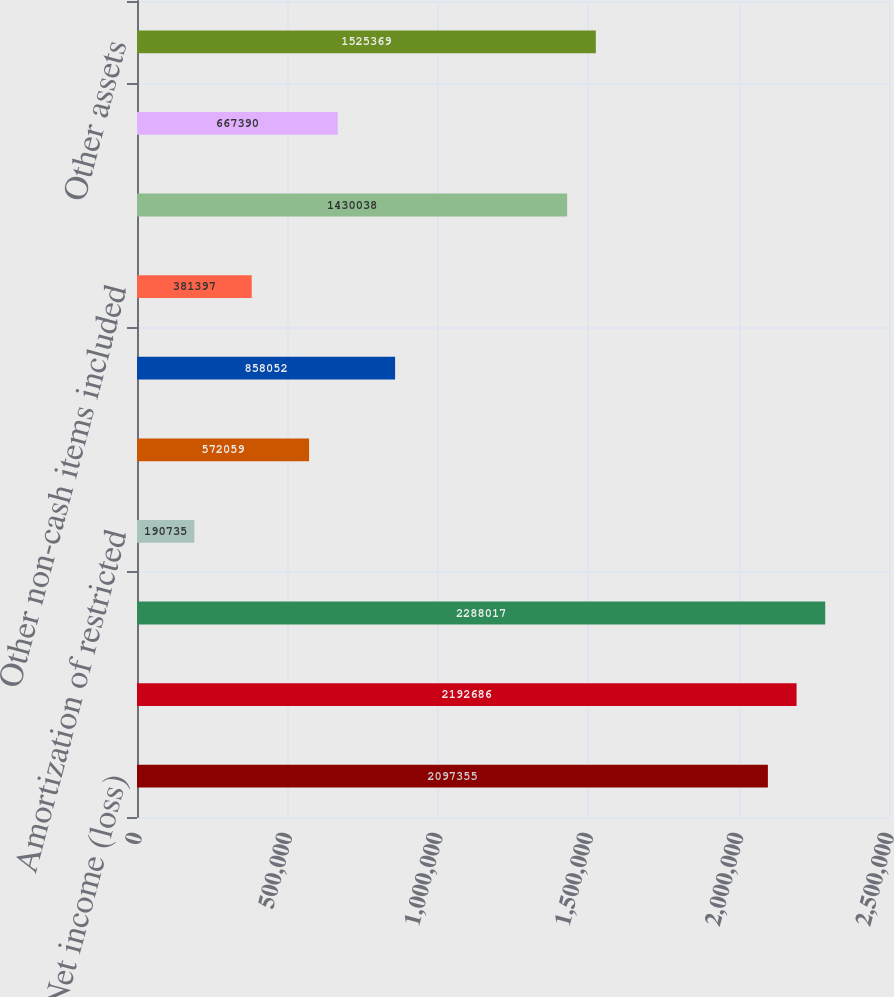Convert chart. <chart><loc_0><loc_0><loc_500><loc_500><bar_chart><fcel>Net income (loss)<fcel>Net income (loss) from<fcel>Depreciation and amortization<fcel>Amortization of restricted<fcel>Provision for bad debts<fcel>Deferred taxes net<fcel>Other non-cash items included<fcel>Receivables net<fcel>Receivables from related<fcel>Other assets<nl><fcel>2.09736e+06<fcel>2.19269e+06<fcel>2.28802e+06<fcel>190735<fcel>572059<fcel>858052<fcel>381397<fcel>1.43004e+06<fcel>667390<fcel>1.52537e+06<nl></chart> 